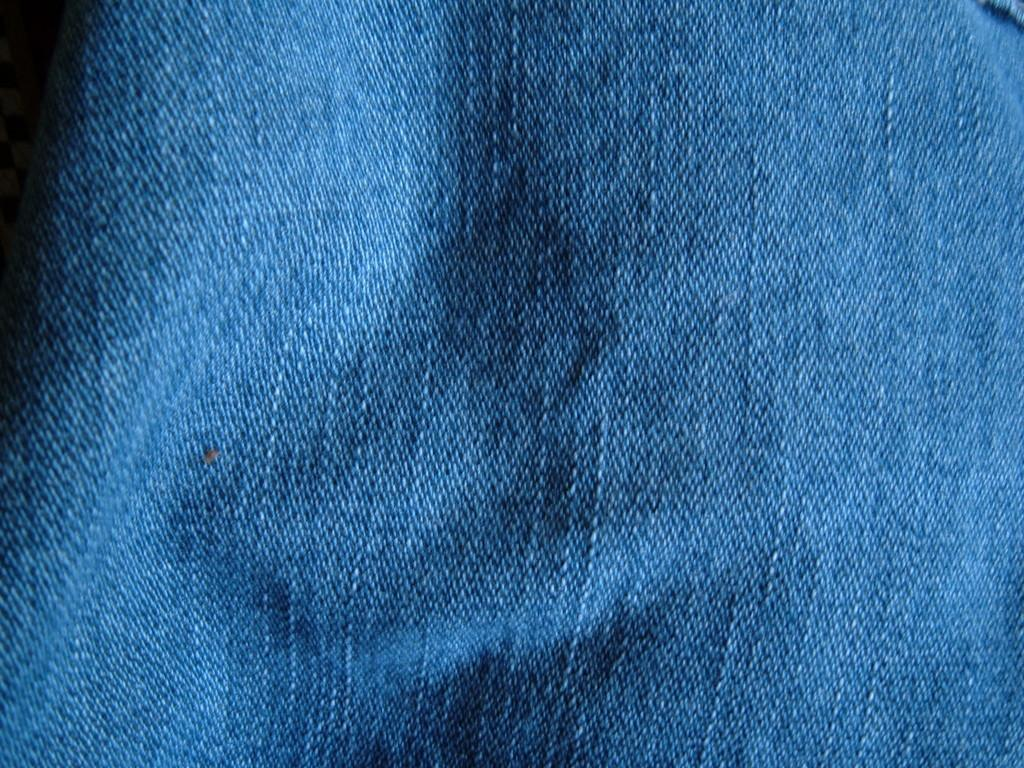What color is the cloth in the image? The cloth in the image is blue. How many passengers are mentioned on the list in the image? There is no list or mention of passengers in the image; it only features a blue color cloth. 